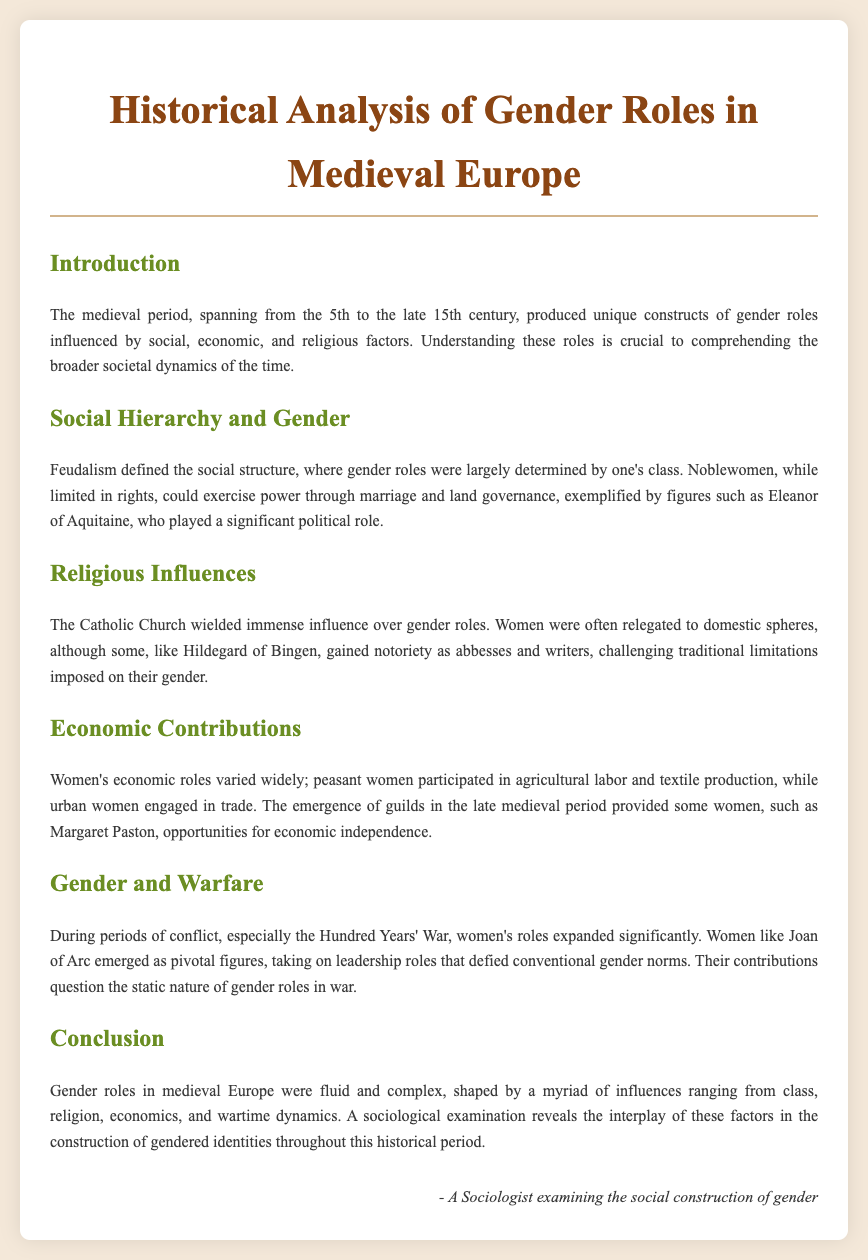What period does the medieval era span? The medieval period is defined as spanning from the 5th to the late 15th century.
Answer: 5th to late 15th century Who is an example of a noblewoman who exercised power? Eleanor of Aquitaine is cited as a significant figure who played a political role and exercised power through marriage and land governance.
Answer: Eleanor of Aquitaine What role did the Catholic Church play in gender roles? The Catholic Church wielded immense influence, often relegating women to domestic spheres, but some women gained notoriety and challenged these limitations.
Answer: Immense influence Who was a notable abbess and writer that gained recognition? Hildegard of Bingen is mentioned as gaining notoriety as an abbess and writer.
Answer: Hildegard of Bingen What economic roles did peasant women have? Peasant women participated in agricultural labor and textile production.
Answer: Agricultural labor and textile production Which war expanded women's roles significantly? The Hundred Years' War is stated to be a period during which women's roles expanded significantly.
Answer: Hundred Years' War What does the document suggest about the nature of gender roles? The document suggests that gender roles in medieval Europe were fluid and complex, shaped by various influences.
Answer: Fluid and complex Who is mentioned as a pivotal figure during wartime? Joan of Arc is highlighted as a pivotal figure who took on leadership roles that defied conventional gender norms.
Answer: Joan of Arc What is the focus of this historical analysis? The focus is on the social construction of gender roles influenced by social, economic, and religious factors in medieval Europe.
Answer: Social construction of gender roles 